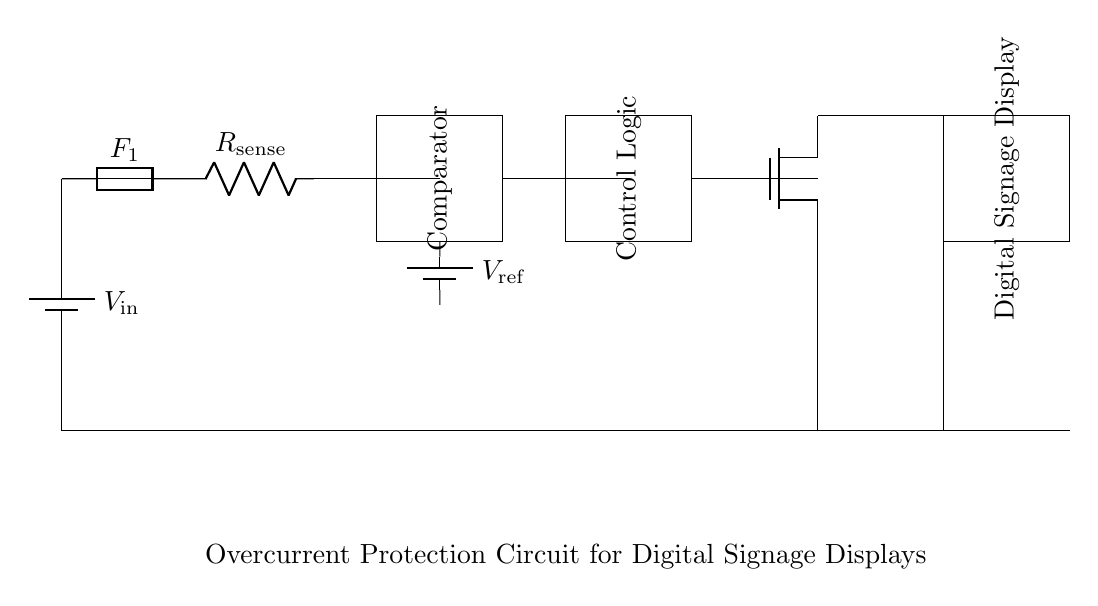What is the input voltage of the circuit? The input voltage is labeled as V_in on the battery symbol, representing the power supply connected to the circuit.
Answer: V_in What is the purpose of the fuse in this circuit? The fuse is a safety device that protects the circuit by breaking the connection in case of an overcurrent, preventing potential damage to the components.
Answer: Overcurrent protection What type of device is used to sense current in the circuit? The current is sensed using a current sense resistor labeled as R_sense, which allows monitoring of the flow of current through it.
Answer: Resistor What component compares the sensed current to a reference voltage? A comparator is used in this circuit to compare the voltage across the sense resistor with the reference voltage to determine if an overcurrent condition exists.
Answer: Comparator How does the MOSFET function in this protection circuit? The MOSFET, identified as Tnmos, acts as a switch controlled by the control logic to disconnect the load from the power supply when an overcurrent condition is detected, thereby providing protection.
Answer: Switch What is the role of the reference voltage in this circuit? The reference voltage, labelled as V_ref, serves as a benchmark that the comparator uses to evaluate whether the sensed current exceeds a predetermined limit set for safe operation.
Answer: Benchmark for comparison What component represents the load in this circuit? The load is represented by the digital signage display, which is connected to the output of the MOSFET, and it is the component that is protected by the overcurrent protection circuit.
Answer: Digital Signage Display 